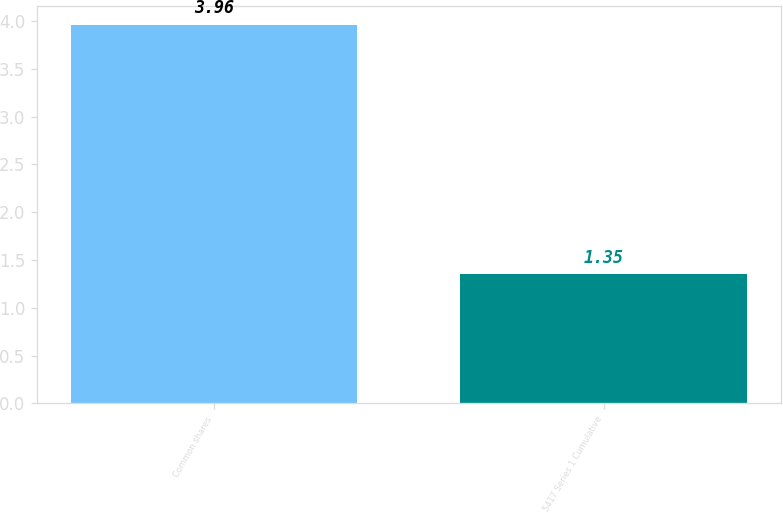Convert chart. <chart><loc_0><loc_0><loc_500><loc_500><bar_chart><fcel>Common shares<fcel>5417 Series 1 Cumulative<nl><fcel>3.96<fcel>1.35<nl></chart> 